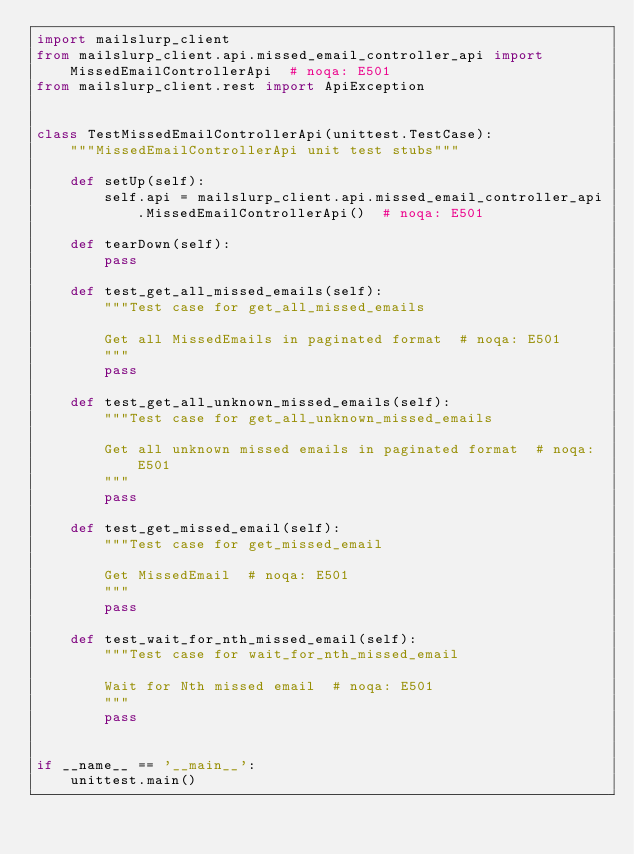Convert code to text. <code><loc_0><loc_0><loc_500><loc_500><_Python_>import mailslurp_client
from mailslurp_client.api.missed_email_controller_api import MissedEmailControllerApi  # noqa: E501
from mailslurp_client.rest import ApiException


class TestMissedEmailControllerApi(unittest.TestCase):
    """MissedEmailControllerApi unit test stubs"""

    def setUp(self):
        self.api = mailslurp_client.api.missed_email_controller_api.MissedEmailControllerApi()  # noqa: E501

    def tearDown(self):
        pass

    def test_get_all_missed_emails(self):
        """Test case for get_all_missed_emails

        Get all MissedEmails in paginated format  # noqa: E501
        """
        pass

    def test_get_all_unknown_missed_emails(self):
        """Test case for get_all_unknown_missed_emails

        Get all unknown missed emails in paginated format  # noqa: E501
        """
        pass

    def test_get_missed_email(self):
        """Test case for get_missed_email

        Get MissedEmail  # noqa: E501
        """
        pass

    def test_wait_for_nth_missed_email(self):
        """Test case for wait_for_nth_missed_email

        Wait for Nth missed email  # noqa: E501
        """
        pass


if __name__ == '__main__':
    unittest.main()
</code> 